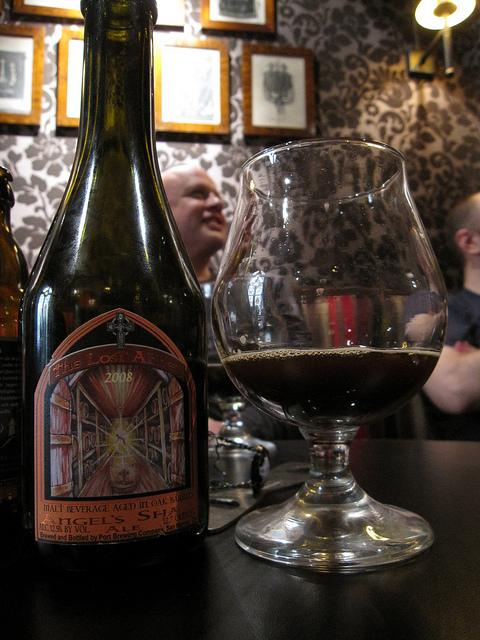What is in the glass?

Choices:
A) juice
B) wine
C) beer
D) gin beer 